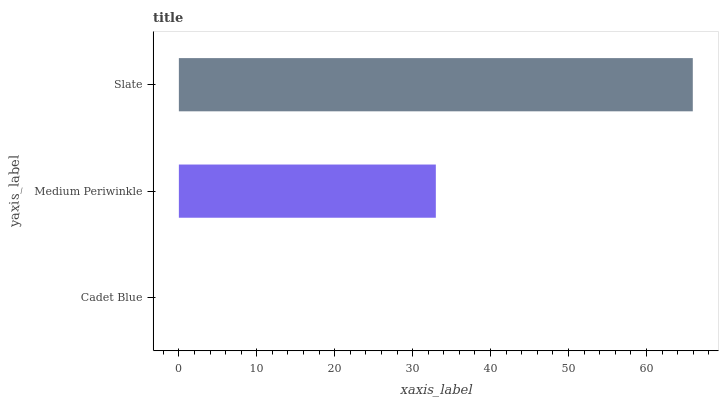Is Cadet Blue the minimum?
Answer yes or no. Yes. Is Slate the maximum?
Answer yes or no. Yes. Is Medium Periwinkle the minimum?
Answer yes or no. No. Is Medium Periwinkle the maximum?
Answer yes or no. No. Is Medium Periwinkle greater than Cadet Blue?
Answer yes or no. Yes. Is Cadet Blue less than Medium Periwinkle?
Answer yes or no. Yes. Is Cadet Blue greater than Medium Periwinkle?
Answer yes or no. No. Is Medium Periwinkle less than Cadet Blue?
Answer yes or no. No. Is Medium Periwinkle the high median?
Answer yes or no. Yes. Is Medium Periwinkle the low median?
Answer yes or no. Yes. Is Slate the high median?
Answer yes or no. No. Is Slate the low median?
Answer yes or no. No. 